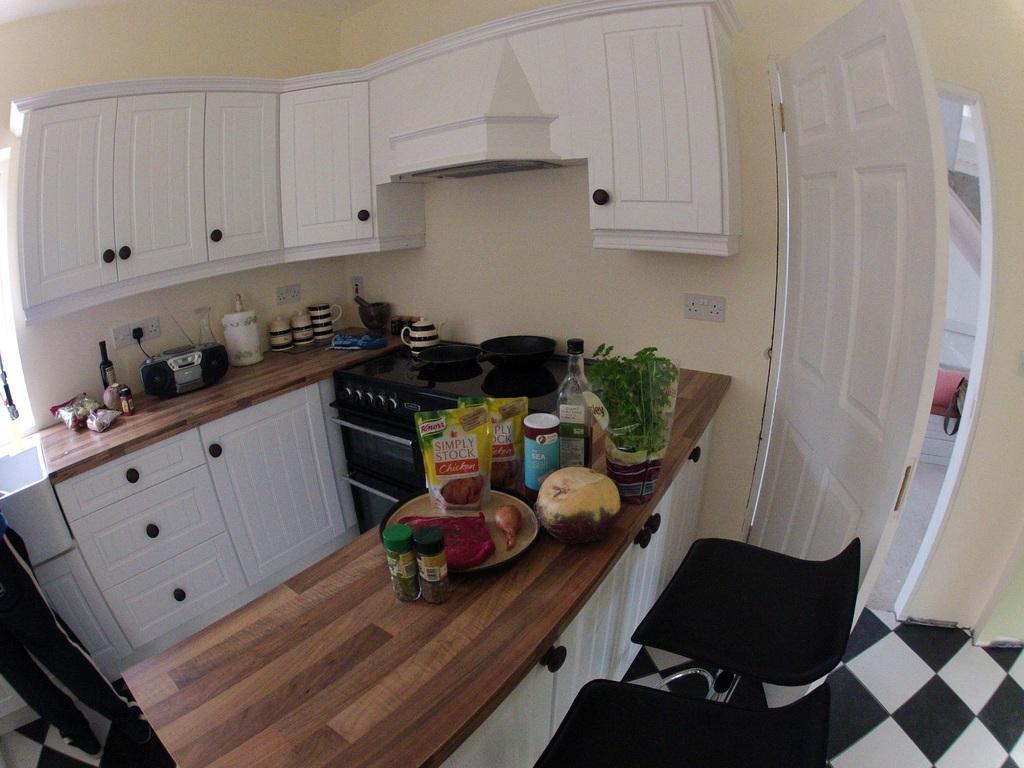In one or two sentences, can you explain what this image depicts? At the bottom of the image there are chairs. In front of the chairs there is a kitchen platform with bottles, plate, packets, potted plant and some other things. Beside that there is a stove with pans and a kettle on it. Beside that stove there is a kitchen platform with cupboards. On that platform there are kettles, cups and also there is a tape record and many other things. Behind them there is a wall with a switch board. At the top of the image there is a cupboard. On the right side of the image there is a wall with a door. 